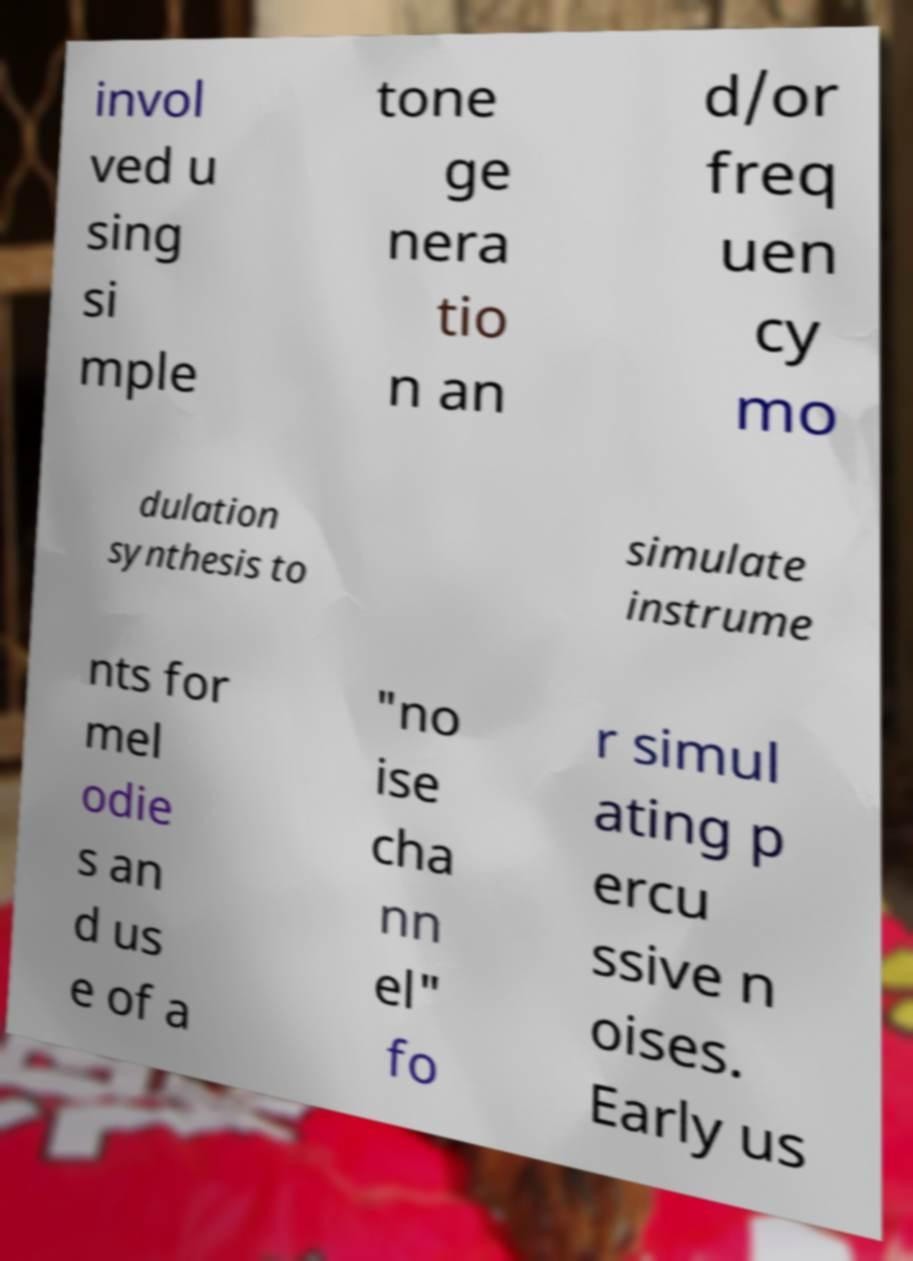There's text embedded in this image that I need extracted. Can you transcribe it verbatim? invol ved u sing si mple tone ge nera tio n an d/or freq uen cy mo dulation synthesis to simulate instrume nts for mel odie s an d us e of a "no ise cha nn el" fo r simul ating p ercu ssive n oises. Early us 